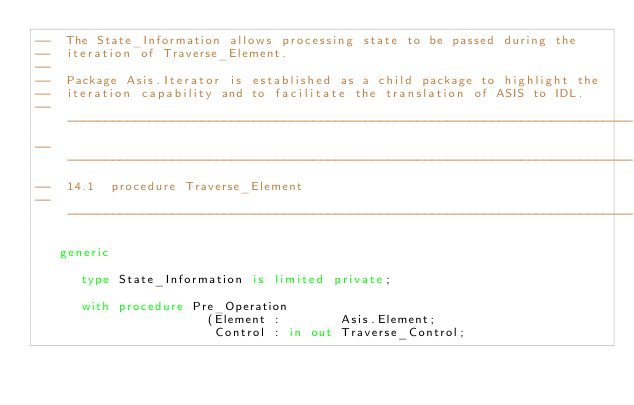<code> <loc_0><loc_0><loc_500><loc_500><_Ada_>--  The State_Information allows processing state to be passed during the
--  iteration of Traverse_Element.
--
--  Package Asis.Iterator is established as a child package to highlight the
--  iteration capability and to facilitate the translation of ASIS to IDL.
------------------------------------------------------------------------------
------------------------------------------------------------------------------
--  14.1  procedure Traverse_Element
------------------------------------------------------------------------------

   generic

      type State_Information is limited private;

      with procedure Pre_Operation
                       (Element :        Asis.Element;
                        Control : in out Traverse_Control;</code> 